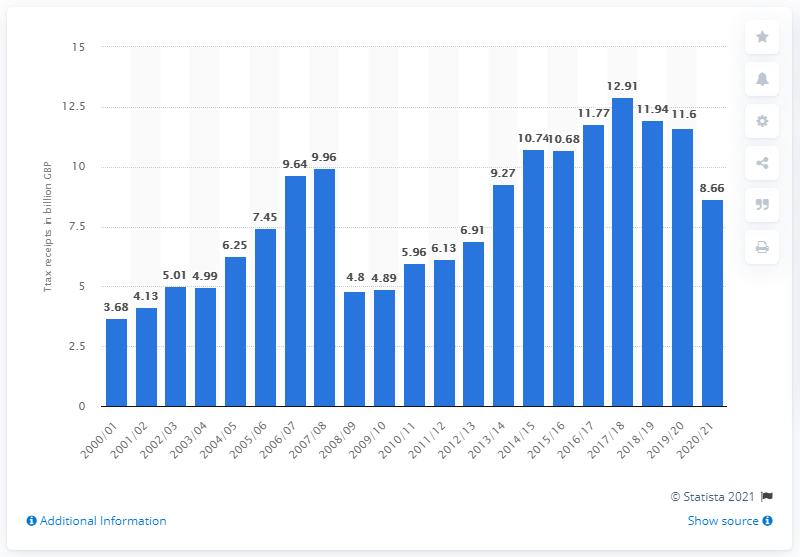Draw attention to some important aspects in this diagram. Last year, the amount of stamp duty land tax receipts in the UK was 11.6... Stamp duty land tax receipts in the UK for the year 2020/21 were 8.66 billion pounds. The highest amount of stamp duty receipts in 2017/2018 was 12.91. 